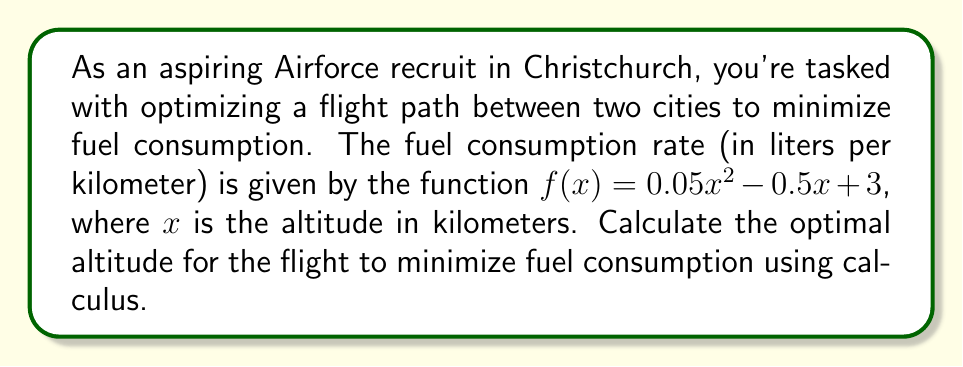Provide a solution to this math problem. To find the optimal altitude that minimizes fuel consumption, we need to find the minimum point of the fuel consumption rate function. This can be done using calculus by following these steps:

1. Given function: $f(x) = 0.05x^2 - 0.5x + 3$

2. To find the minimum point, we need to find where the derivative of the function equals zero. Let's calculate the derivative:

   $f'(x) = 0.1x - 0.5$

3. Set the derivative equal to zero and solve for x:

   $0.1x - 0.5 = 0$
   $0.1x = 0.5$
   $x = 5$

4. To confirm this is a minimum (not a maximum), we can check the second derivative:

   $f''(x) = 0.1$

   Since $f''(x)$ is positive, the critical point at $x = 5$ is indeed a minimum.

5. Therefore, the optimal altitude for minimizing fuel consumption is 5 kilometers.

6. We can calculate the minimum fuel consumption rate by plugging this value back into the original function:

   $f(5) = 0.05(5)^2 - 0.5(5) + 3$
         $= 0.05(25) - 2.5 + 3$
         $= 1.25 - 2.5 + 3$
         $= 1.75$ liters per kilometer

This approach uses the principles of differential calculus to find the optimal solution, which is relevant to both the given topic and the persona of an aspiring Airforce recruit who would need to understand such concepts for efficient flight operations.
Answer: The optimal altitude for minimizing fuel consumption is 5 kilometers, resulting in a minimum fuel consumption rate of 1.75 liters per kilometer. 